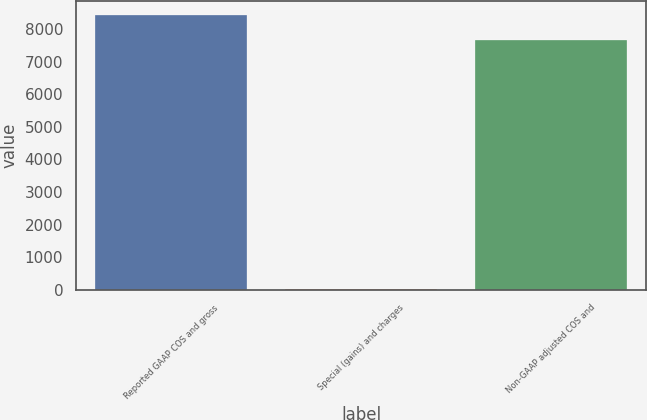Convert chart to OTSL. <chart><loc_0><loc_0><loc_500><loc_500><bar_chart><fcel>Reported GAAP COS and gross<fcel>Special (gains) and charges<fcel>Non-GAAP adjusted COS and<nl><fcel>8431.28<fcel>14.3<fcel>7664.8<nl></chart> 